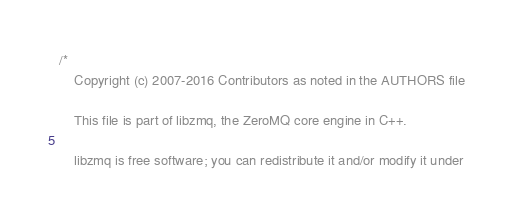Convert code to text. <code><loc_0><loc_0><loc_500><loc_500><_C++_>/*
    Copyright (c) 2007-2016 Contributors as noted in the AUTHORS file

    This file is part of libzmq, the ZeroMQ core engine in C++.

    libzmq is free software; you can redistribute it and/or modify it under</code> 